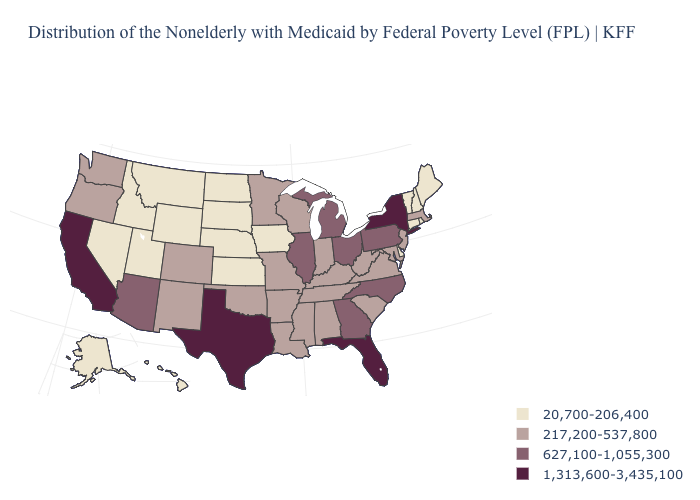What is the value of Maryland?
Quick response, please. 217,200-537,800. Name the states that have a value in the range 217,200-537,800?
Be succinct. Alabama, Arkansas, Colorado, Indiana, Kentucky, Louisiana, Maryland, Massachusetts, Minnesota, Mississippi, Missouri, New Jersey, New Mexico, Oklahoma, Oregon, South Carolina, Tennessee, Virginia, Washington, West Virginia, Wisconsin. Name the states that have a value in the range 627,100-1,055,300?
Write a very short answer. Arizona, Georgia, Illinois, Michigan, North Carolina, Ohio, Pennsylvania. What is the value of Louisiana?
Be succinct. 217,200-537,800. Which states have the highest value in the USA?
Keep it brief. California, Florida, New York, Texas. Name the states that have a value in the range 217,200-537,800?
Short answer required. Alabama, Arkansas, Colorado, Indiana, Kentucky, Louisiana, Maryland, Massachusetts, Minnesota, Mississippi, Missouri, New Jersey, New Mexico, Oklahoma, Oregon, South Carolina, Tennessee, Virginia, Washington, West Virginia, Wisconsin. Does Alaska have the same value as North Dakota?
Answer briefly. Yes. Does Wyoming have a higher value than Nebraska?
Write a very short answer. No. Name the states that have a value in the range 1,313,600-3,435,100?
Answer briefly. California, Florida, New York, Texas. Name the states that have a value in the range 1,313,600-3,435,100?
Keep it brief. California, Florida, New York, Texas. What is the value of New Hampshire?
Short answer required. 20,700-206,400. Does California have a higher value than New York?
Answer briefly. No. Among the states that border Georgia , which have the lowest value?
Short answer required. Alabama, South Carolina, Tennessee. Does Massachusetts have a higher value than Delaware?
Quick response, please. Yes. What is the value of Missouri?
Answer briefly. 217,200-537,800. 